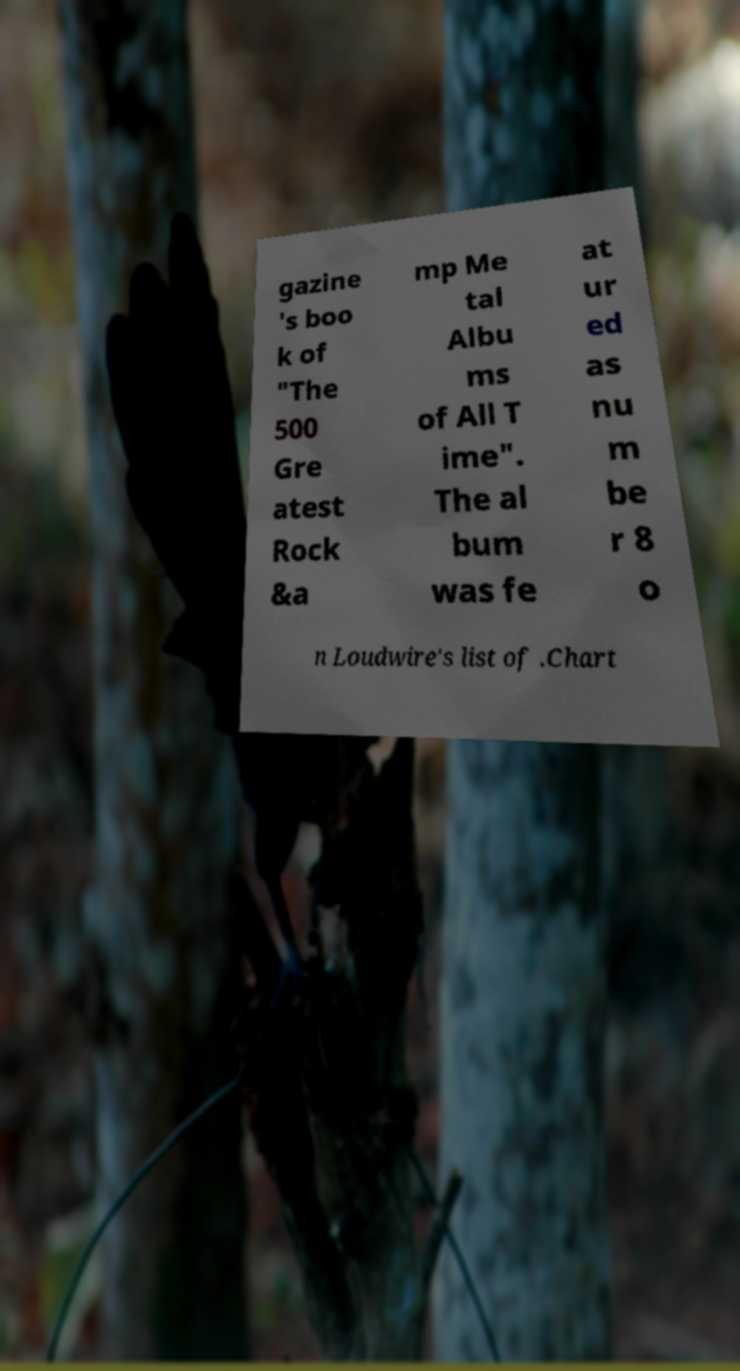Could you assist in decoding the text presented in this image and type it out clearly? gazine 's boo k of "The 500 Gre atest Rock &a mp Me tal Albu ms of All T ime". The al bum was fe at ur ed as nu m be r 8 o n Loudwire's list of .Chart 